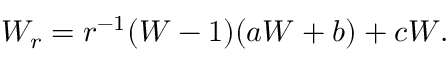Convert formula to latex. <formula><loc_0><loc_0><loc_500><loc_500>W _ { r } = r ^ { - 1 } ( W - 1 ) ( a W + b ) + c W .</formula> 